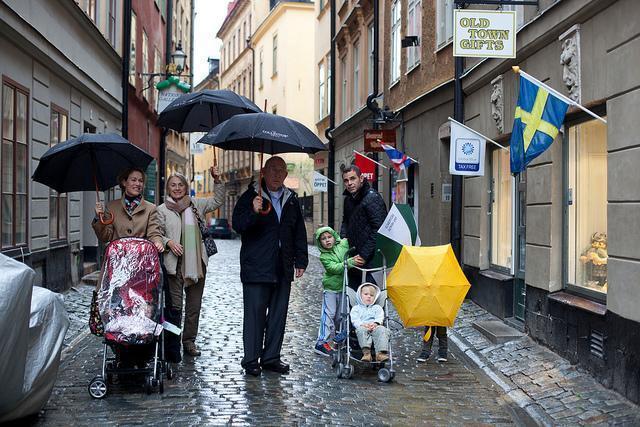What kind of flag is the blue and yellow one?
Choose the correct response and explain in the format: 'Answer: answer
Rationale: rationale.'
Options: Swedens flag, scotlands flag, germanys flag, denmarks flag. Answer: swedens flag.
Rationale: The flag is sweden's. 